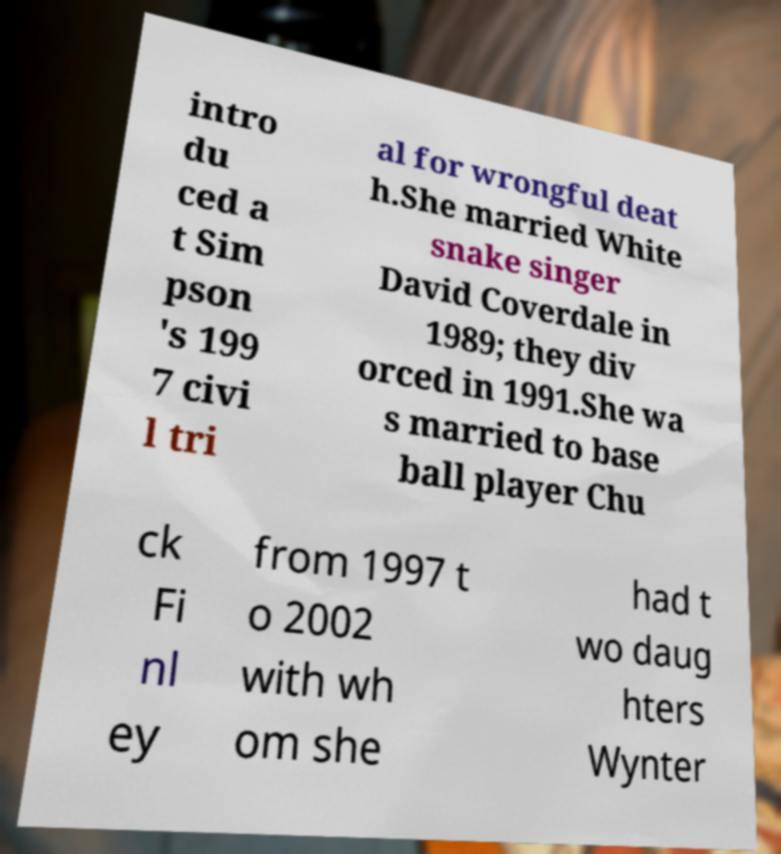Can you read and provide the text displayed in the image?This photo seems to have some interesting text. Can you extract and type it out for me? intro du ced a t Sim pson 's 199 7 civi l tri al for wrongful deat h.She married White snake singer David Coverdale in 1989; they div orced in 1991.She wa s married to base ball player Chu ck Fi nl ey from 1997 t o 2002 with wh om she had t wo daug hters Wynter 